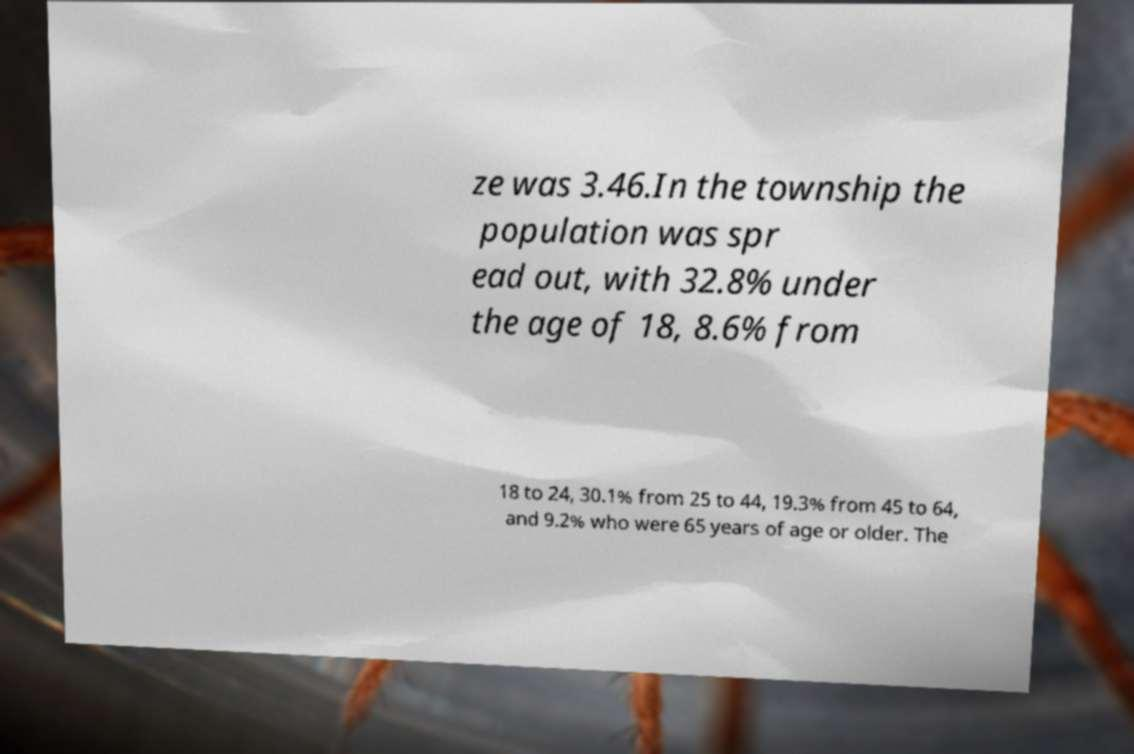There's text embedded in this image that I need extracted. Can you transcribe it verbatim? ze was 3.46.In the township the population was spr ead out, with 32.8% under the age of 18, 8.6% from 18 to 24, 30.1% from 25 to 44, 19.3% from 45 to 64, and 9.2% who were 65 years of age or older. The 